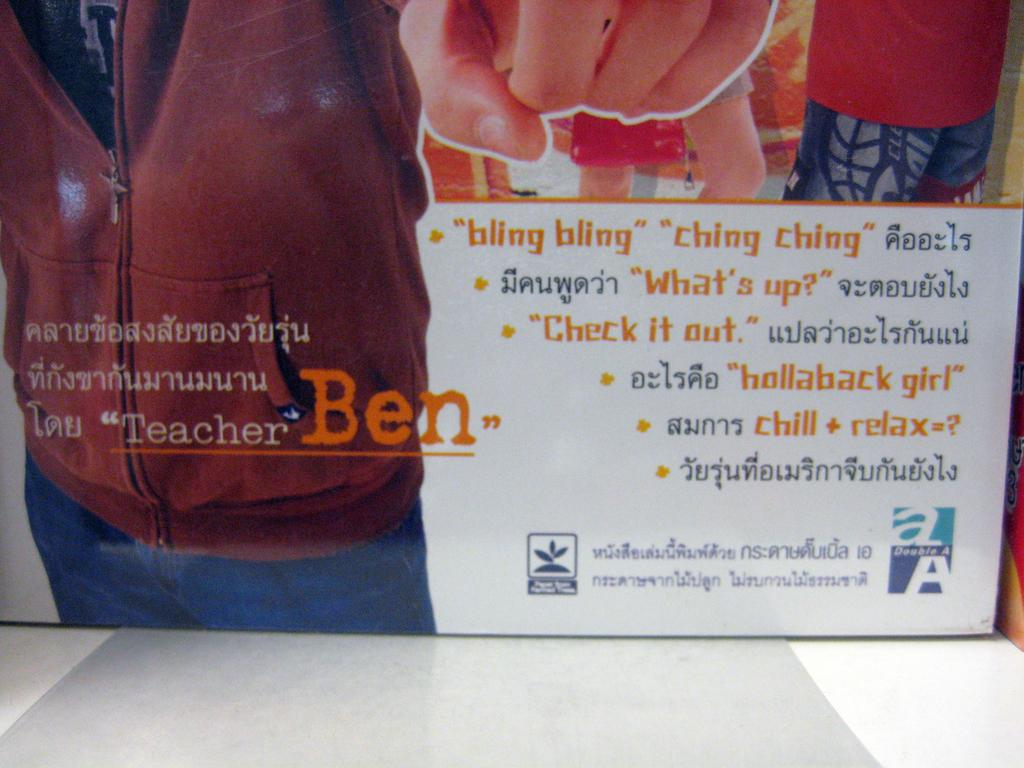What is present in the image that has writing on it? There is a banner in the image that has writing on it. What else can be seen near the banner? There is a picture beside the banner. Is the dock visible in the image? There is no dock present in the image. What is the temperature of the hot item in the image? There is no hot item present in the image. 